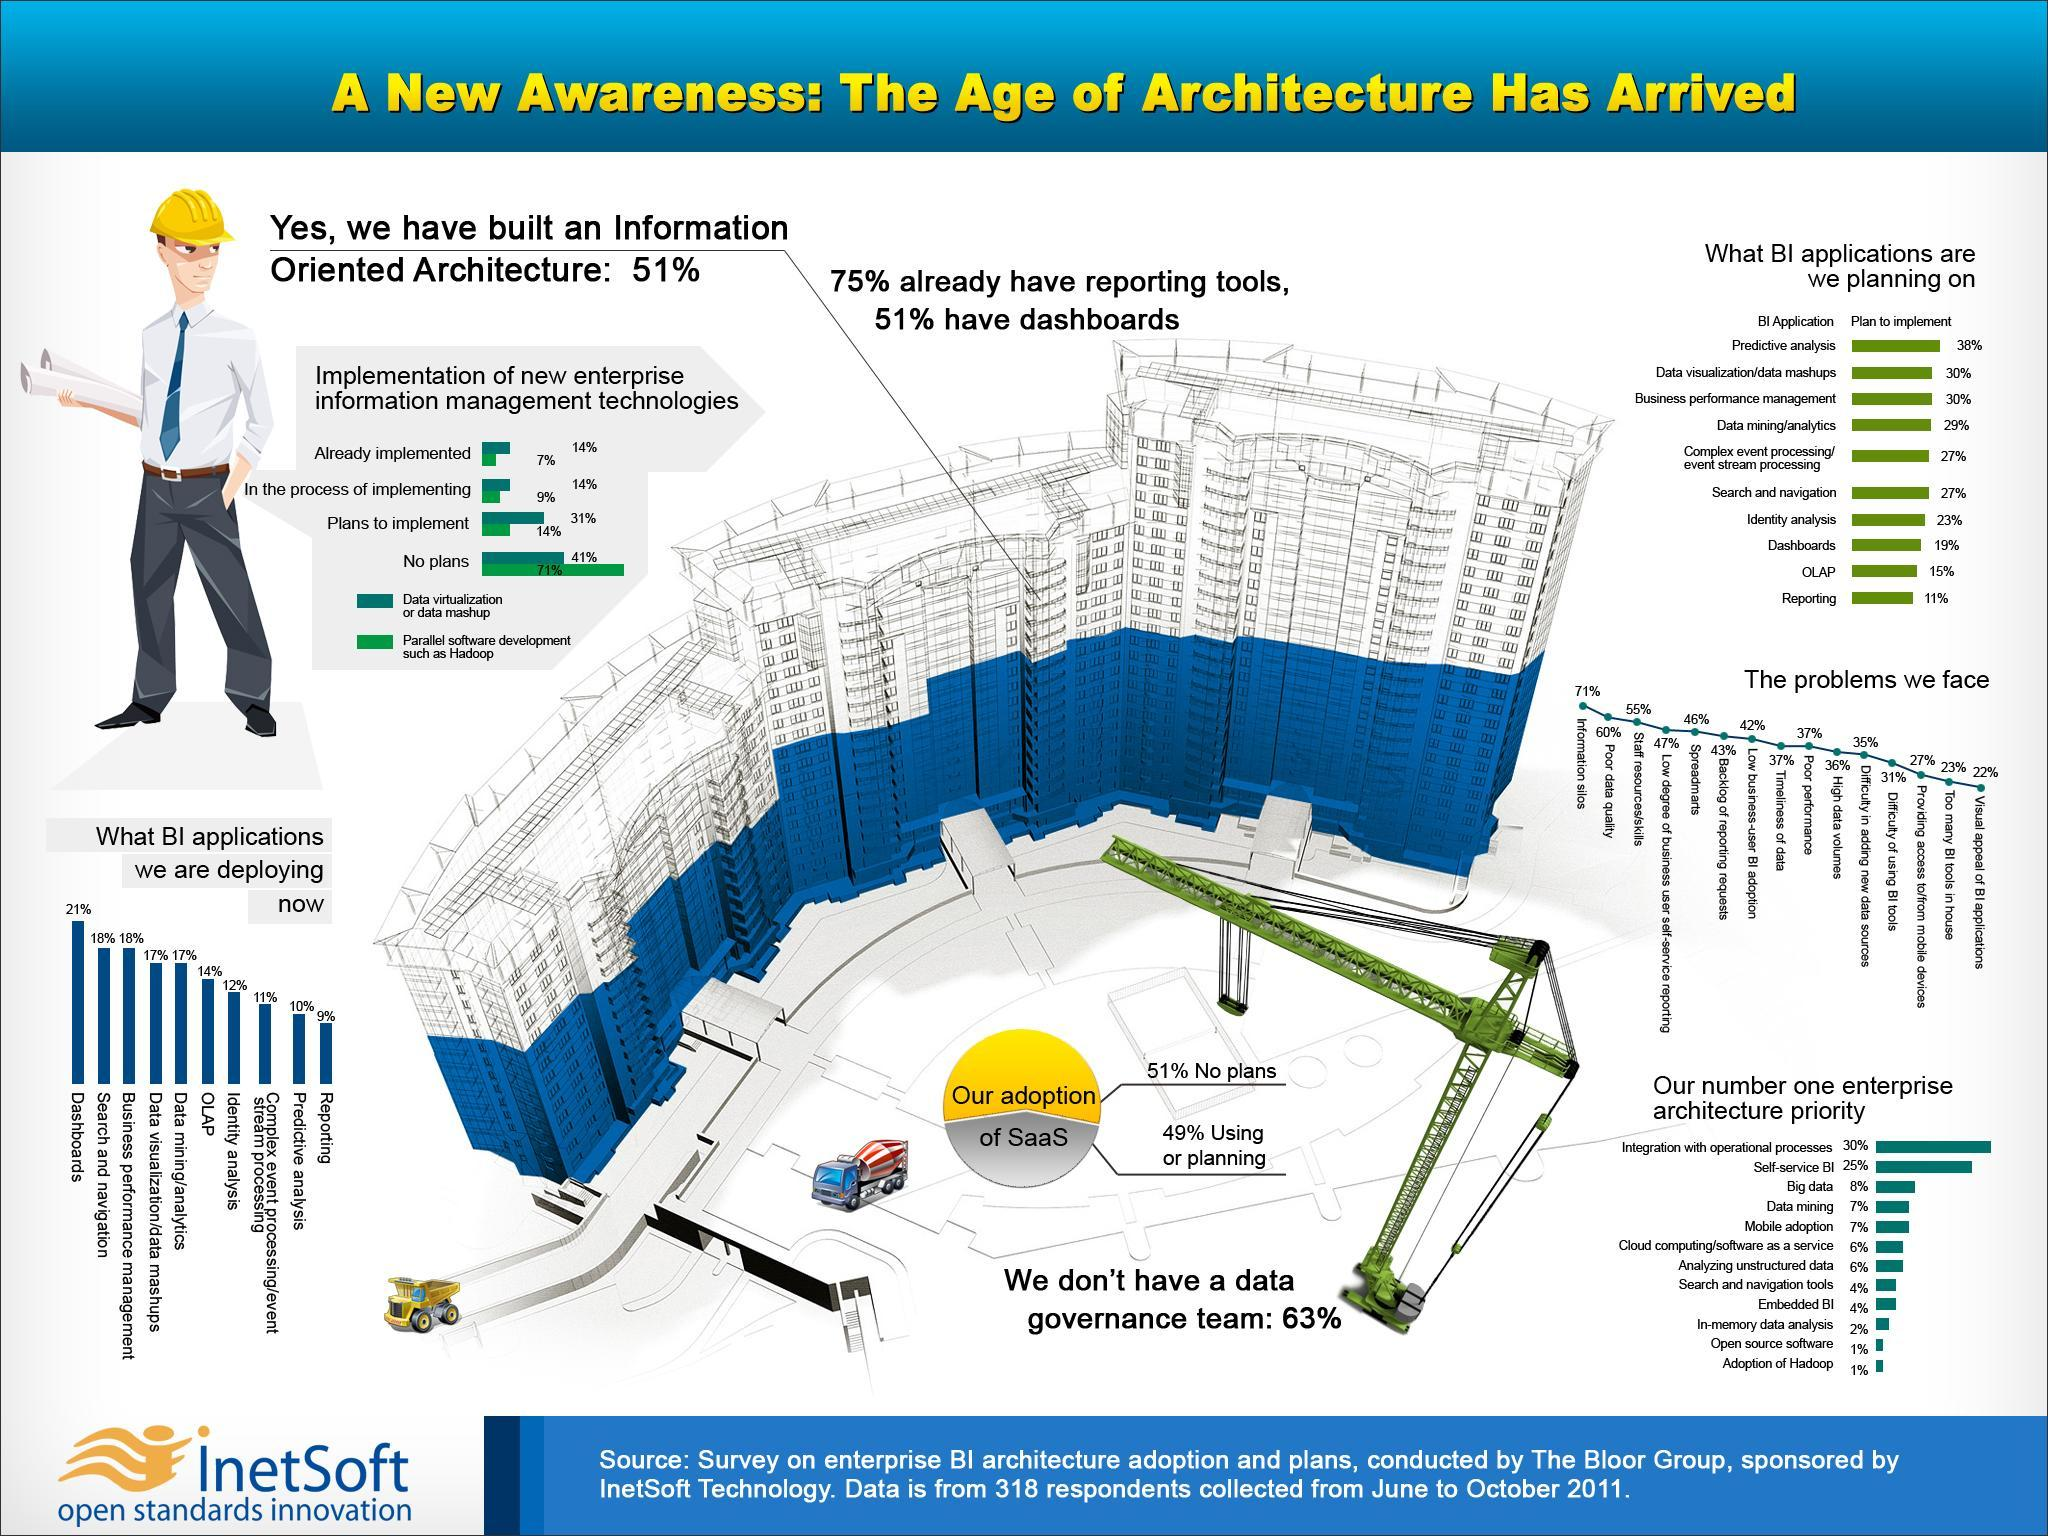What type of BI application is planned to implement in in 23% of the enterprise architecture according to the survey in 2011?
Answer the question with a short phrase. Identity analysis What percentage of enterprises already implemented data visualization or mashup as per the survey in 2011? 14% What problem is faced by majority of the enterprises in deploying BI applications as per the survey in 2011? Information silos What percentage of enterprises are in the process of  implementing parallel software development such as Hadoop as per the survey in 2011? 9% What percentage of enterprises have no plans to implement parallel software development such as Hadoop as per the survey in 2011? 71% What type of BI application is deployed in 21% of the enterprise architecture according to the survey in 2011? Dashboards What type of BI application is planned to implement in in 29% of the enterprise architecture according to the survey in 2011? Data mining/analytics What percentage of enterprises have no plans to implement data visualization or mashup as per the survey in 2011? 41% What type of BI application is deployed in 10% of the enterprise architecture according to the survey in 2011? Predictive analysis What type of BI application is deployed in 14% of the enterprise architecture according to the survey in 2011? OLAP 